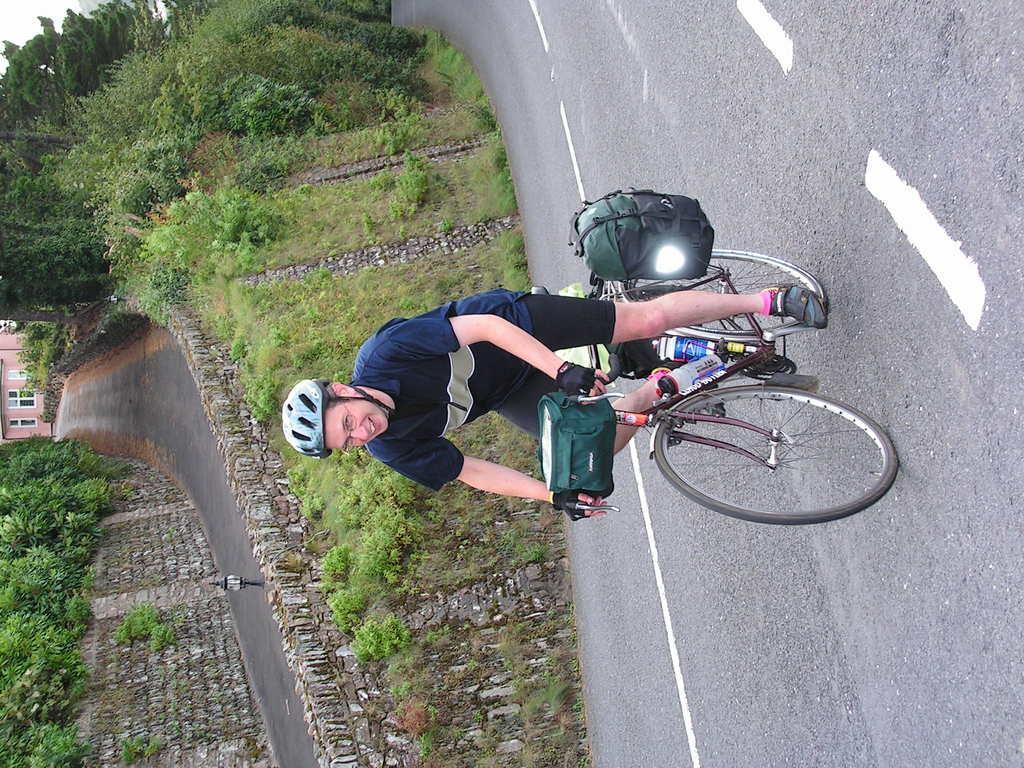Describe this image in one or two sentences. In this image I can see a person wearing blue, white and black colored dress is riding a bicycle and I can see two green colored bags on the bicycle. I can see the road, some grass, few plants, a building, few trees and a sky in the background. 